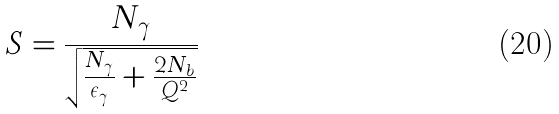<formula> <loc_0><loc_0><loc_500><loc_500>S = \frac { N _ { \gamma } } { \sqrt { \frac { N _ { \gamma } } { \epsilon _ { \gamma } } + \frac { 2 N _ { b } } { Q ^ { 2 } } } }</formula> 